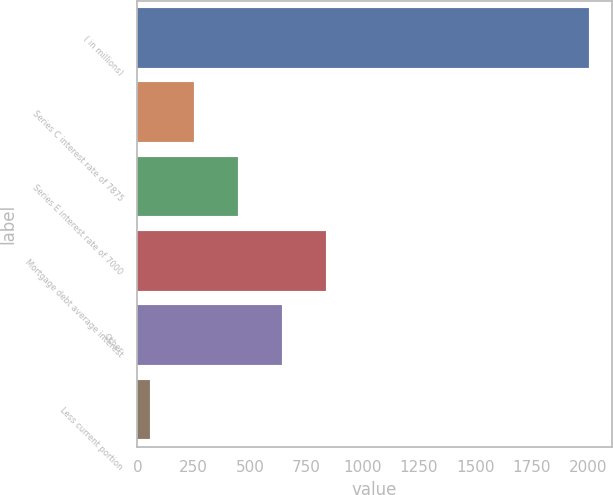Convert chart to OTSL. <chart><loc_0><loc_0><loc_500><loc_500><bar_chart><fcel>( in millions)<fcel>Series C interest rate of 7875<fcel>Series E interest rate of 7000<fcel>Mortgage debt average interest<fcel>Other<fcel>Less current portion<nl><fcel>2005<fcel>250.9<fcel>445.8<fcel>835.6<fcel>640.7<fcel>56<nl></chart> 